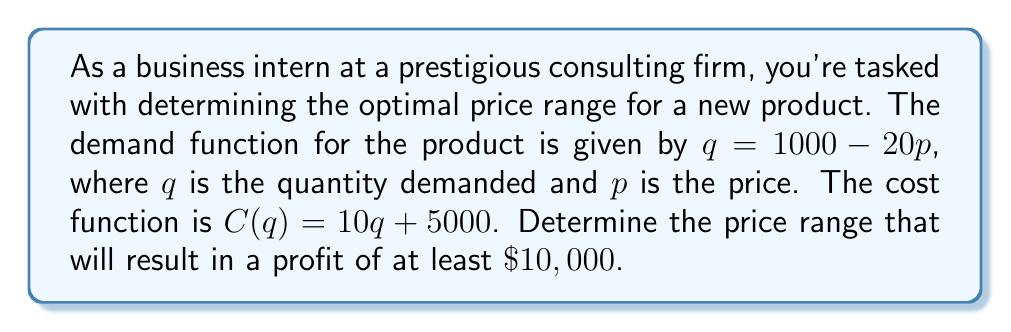Solve this math problem. To solve this problem, we'll follow these steps:

1) First, let's define the profit function. Profit is revenue minus cost:
   $\Pi(p) = R(p) - C(q)$

2) Revenue is price times quantity: $R(p) = pq = p(1000 - 20p)$

3) We need to express the cost function in terms of $p$:
   $C(q) = 10q + 5000 = 10(1000 - 20p) + 5000 = 10000 - 200p + 5000 = 15000 - 200p$

4) Now we can write the profit function:
   $\Pi(p) = p(1000 - 20p) - (15000 - 200p)$
   $\Pi(p) = 1000p - 20p^2 - 15000 + 200p$
   $\Pi(p) = -20p^2 + 1200p - 15000$

5) We want profit to be at least $10,000, so:
   $-20p^2 + 1200p - 15000 \geq 10000$
   $-20p^2 + 1200p - 25000 \geq 0$

6) Solve this quadratic inequality:
   $-20(p^2 - 60p + 1250) \geq 0$
   $-20(p - 25)(p - 35) \geq 0$

7) The inequality is satisfied when $25 \leq p \leq 35$

Therefore, the price should be between $25 and $35 to ensure a profit of at least $10,000.
Answer: The optimal price range is $25 \leq p \leq 35$. 